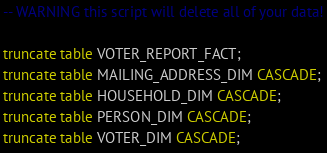<code> <loc_0><loc_0><loc_500><loc_500><_SQL_>
-- WARNING this script will delete all of your data!

truncate table VOTER_REPORT_FACT;
truncate table MAILING_ADDRESS_DIM CASCADE;
truncate table HOUSEHOLD_DIM CASCADE;
truncate table PERSON_DIM CASCADE;
truncate table VOTER_DIM CASCADE;

</code> 